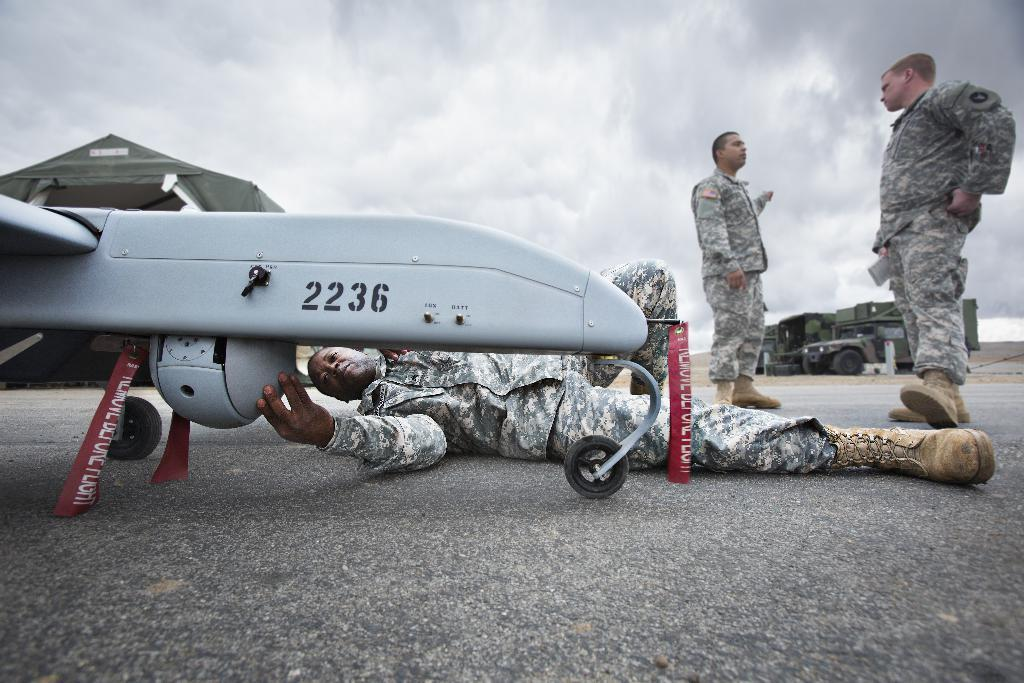Provide a one-sentence caption for the provided image. Army soldiers are fixing a piece of equipment with a black knob on the side and numbers 2236. 